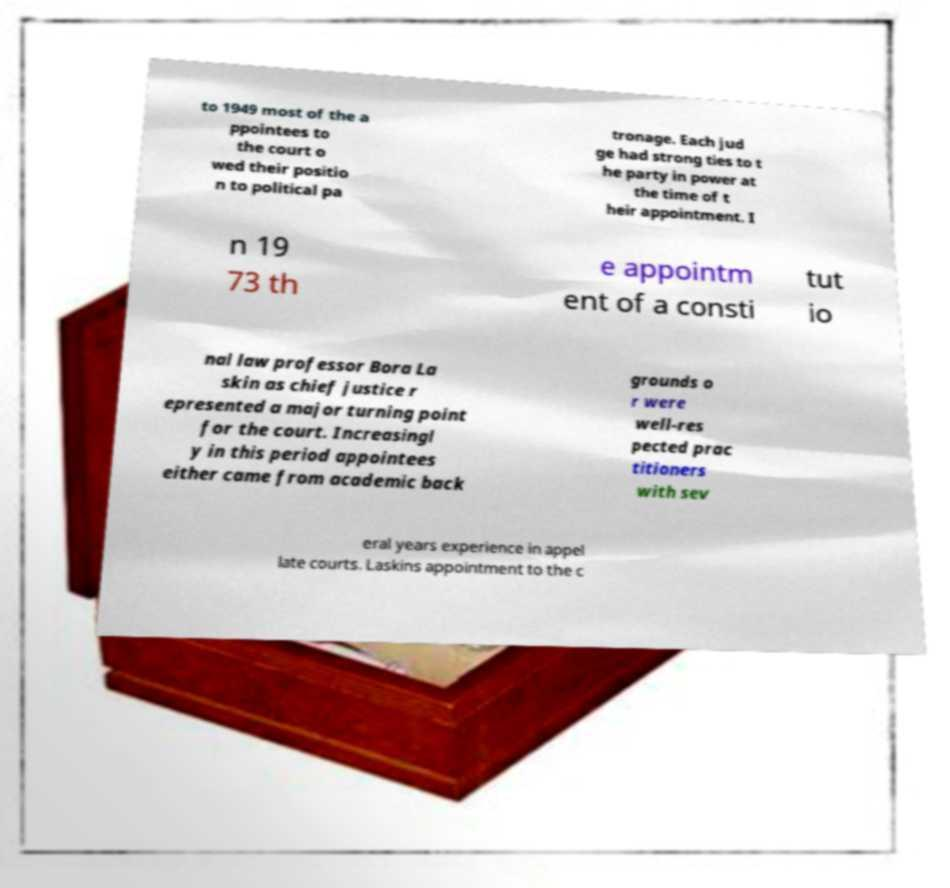Can you accurately transcribe the text from the provided image for me? to 1949 most of the a ppointees to the court o wed their positio n to political pa tronage. Each jud ge had strong ties to t he party in power at the time of t heir appointment. I n 19 73 th e appointm ent of a consti tut io nal law professor Bora La skin as chief justice r epresented a major turning point for the court. Increasingl y in this period appointees either came from academic back grounds o r were well-res pected prac titioners with sev eral years experience in appel late courts. Laskins appointment to the c 